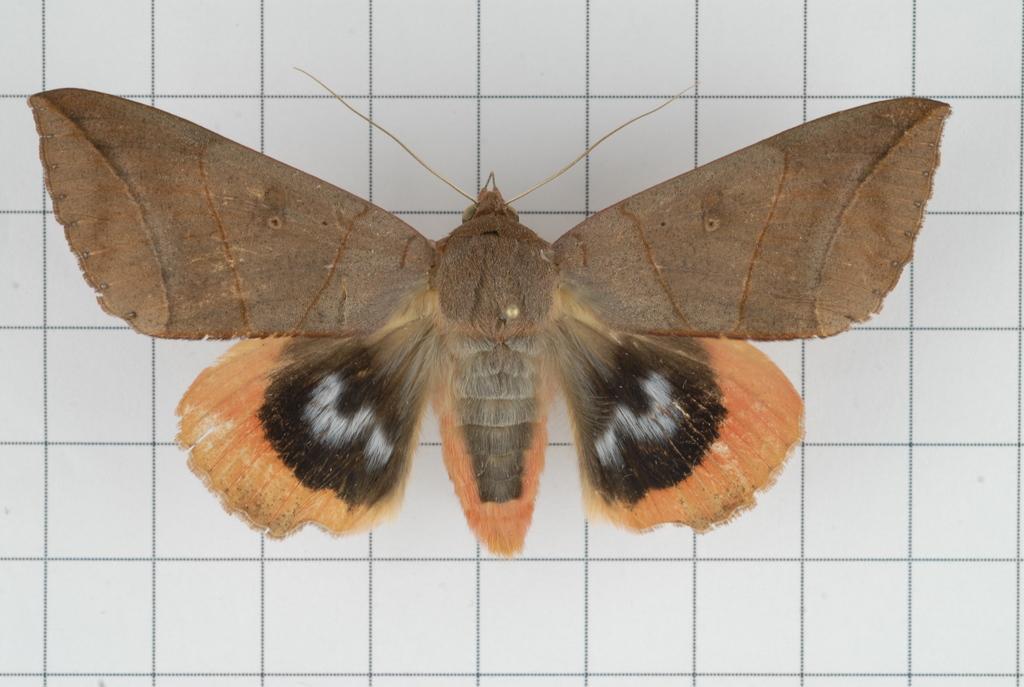Could you give a brief overview of what you see in this image? It looks like a picture of butterfly. And there is a wall in the background. 